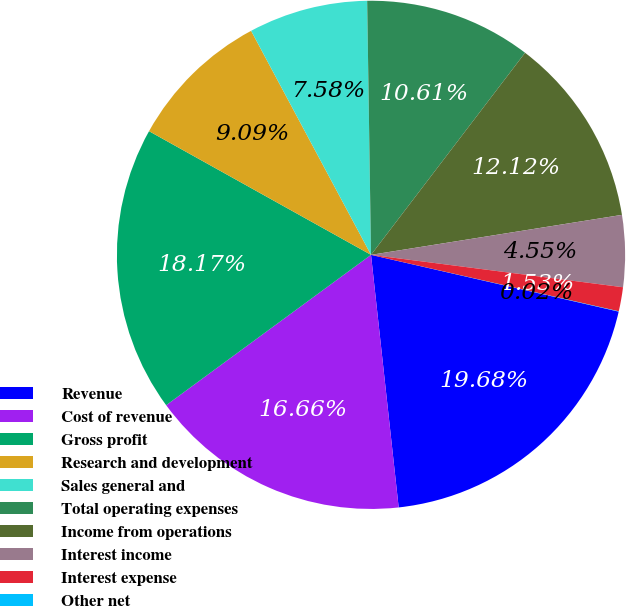Convert chart. <chart><loc_0><loc_0><loc_500><loc_500><pie_chart><fcel>Revenue<fcel>Cost of revenue<fcel>Gross profit<fcel>Research and development<fcel>Sales general and<fcel>Total operating expenses<fcel>Income from operations<fcel>Interest income<fcel>Interest expense<fcel>Other net<nl><fcel>19.68%<fcel>16.66%<fcel>18.17%<fcel>9.09%<fcel>7.58%<fcel>10.61%<fcel>12.12%<fcel>4.55%<fcel>1.53%<fcel>0.02%<nl></chart> 